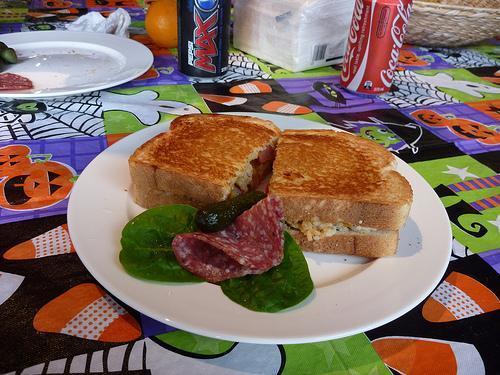How many pieces has the sandwich been cut into?
Give a very brief answer. 2. 